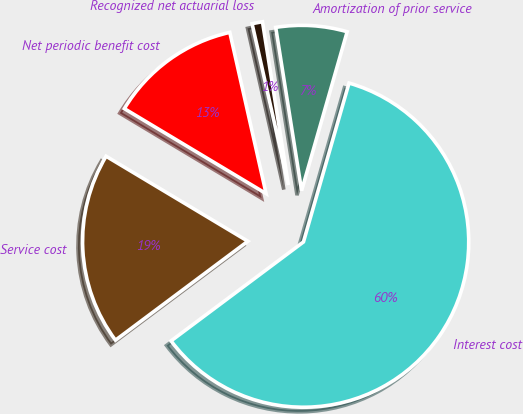<chart> <loc_0><loc_0><loc_500><loc_500><pie_chart><fcel>Service cost<fcel>Interest cost<fcel>Amortization of prior service<fcel>Recognized net actuarial loss<fcel>Net periodic benefit cost<nl><fcel>18.81%<fcel>60.34%<fcel>6.95%<fcel>1.02%<fcel>12.88%<nl></chart> 